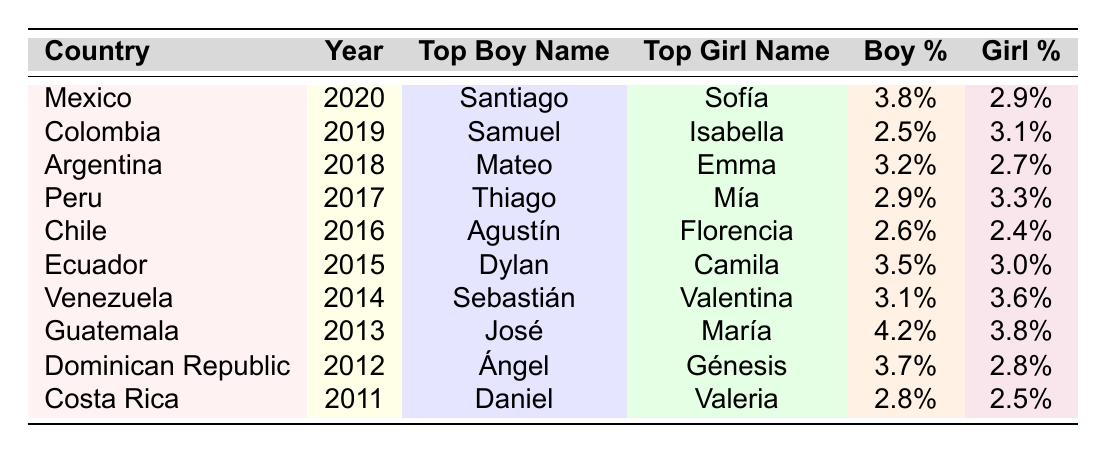What was the top boy name in Mexico in 2020? According to the table, the top boy name in Mexico for the year 2020 is Santiago.
Answer: Santiago Which country had the highest percentage for the top girl name in 2014? In 2014, Venezuela had the highest percentage for the top girl name, Valentina, at 3.6%.
Answer: Venezuela What is the boy name popularity percentage for Argentina in 2018? The boy name popularity percentage for Argentina in 2018 is 3.2%.
Answer: 3.2% What is the average boy name popularity of all countries listed? To find the average boy name popularity, add the percentages (3.8 + 2.5 + 3.2 + 2.9 + 2.6 + 3.5 + 3.1 + 4.2 + 3.7 + 2.8) to get 30.3. Divide by the number of countries (10) to get 3.03.
Answer: 3.03% Which top girl name had the lowest popularity? The lowest popularity for a top girl name in the table is 2.4%, associated with Florencia in Chile in 2016.
Answer: 2.4% Is "José" a top boy name for Guatemala? Yes, "José" is listed as the top boy name for Guatemala in 2013 according to the table.
Answer: Yes What was the top girl name in both Ecuador (2015) and Colombia (2019)? The top girl name in Ecuador in 2015 was Camila, and in Colombia in 2019, it was Isabella. These names are different for each country and year.
Answer: Different names How many countries had a top boy name popularity percentage over 3%? From the table, there are five countries (Mexico, Ecuador, Venezuela, Guatemala, and Dominican Republic) with a top boy name popularity over 3%.
Answer: Five countries What was the progression of the top boy name from Costa Rica (2011) to Peru (2017)? The top boy names from Costa Rica to Peru were Daniel (2011), then Ángel (2012), José (2013), Sebastián (2014), Dylan (2015), Agustín (2016), and finally Thiago (2017). This shows a variety of popular names over the years.
Answer: Varied names In which year did "Mía" become the top girl name? According to the table, "Mía" became the top girl name in Peru in 2017.
Answer: 2017 Do any top names repeat across countries? Based on the data provided, there are no exact repetitions of top names across different countries in the years listed.
Answer: No 